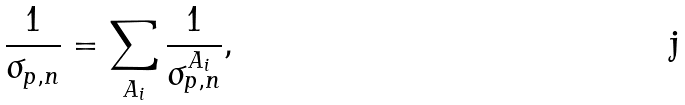Convert formula to latex. <formula><loc_0><loc_0><loc_500><loc_500>\frac { 1 } { \sigma _ { p , n } } = \sum _ { A _ { i } } \frac { 1 } { \sigma _ { p , n } ^ { A _ { i } } } ,</formula> 